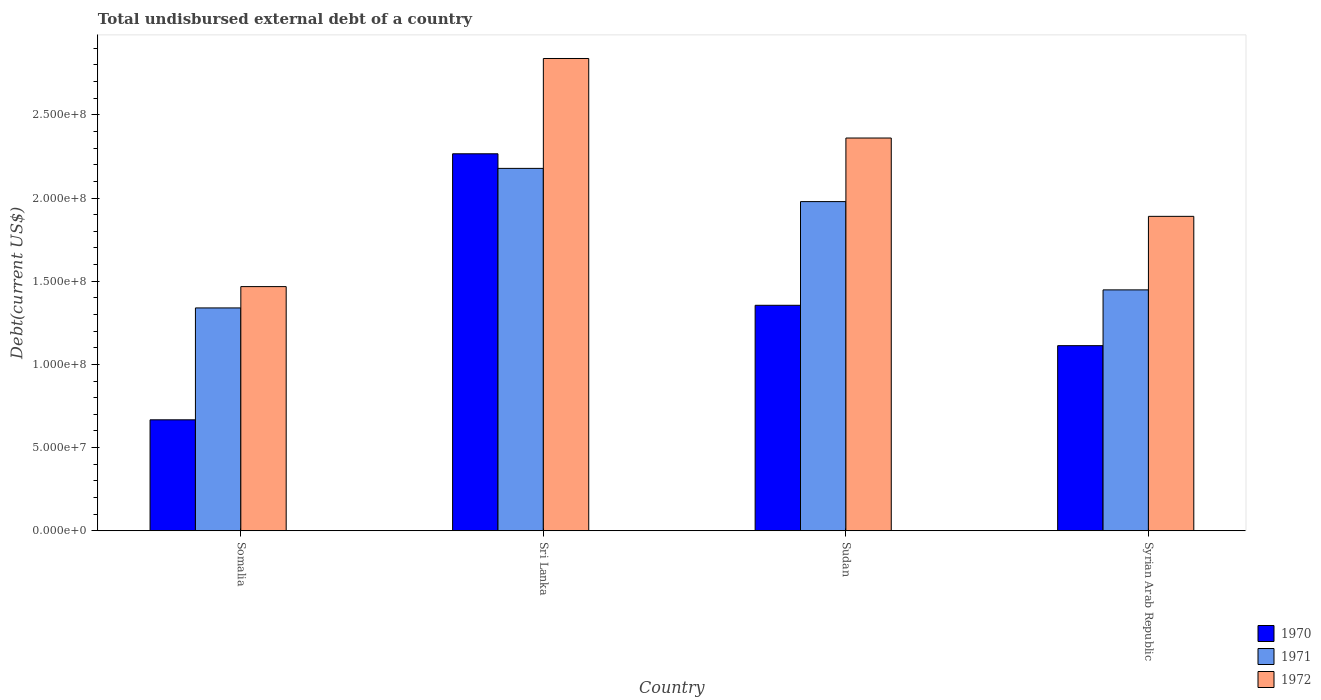How many different coloured bars are there?
Your answer should be compact. 3. Are the number of bars on each tick of the X-axis equal?
Your answer should be compact. Yes. What is the label of the 4th group of bars from the left?
Make the answer very short. Syrian Arab Republic. In how many cases, is the number of bars for a given country not equal to the number of legend labels?
Offer a very short reply. 0. What is the total undisbursed external debt in 1971 in Somalia?
Ensure brevity in your answer.  1.34e+08. Across all countries, what is the maximum total undisbursed external debt in 1972?
Your response must be concise. 2.84e+08. Across all countries, what is the minimum total undisbursed external debt in 1972?
Your answer should be compact. 1.47e+08. In which country was the total undisbursed external debt in 1970 maximum?
Offer a terse response. Sri Lanka. In which country was the total undisbursed external debt in 1971 minimum?
Offer a terse response. Somalia. What is the total total undisbursed external debt in 1970 in the graph?
Ensure brevity in your answer.  5.40e+08. What is the difference between the total undisbursed external debt in 1971 in Sri Lanka and that in Syrian Arab Republic?
Make the answer very short. 7.30e+07. What is the difference between the total undisbursed external debt in 1972 in Syrian Arab Republic and the total undisbursed external debt in 1971 in Sri Lanka?
Your answer should be compact. -2.88e+07. What is the average total undisbursed external debt in 1970 per country?
Provide a short and direct response. 1.35e+08. What is the difference between the total undisbursed external debt of/in 1972 and total undisbursed external debt of/in 1971 in Somalia?
Your response must be concise. 1.28e+07. In how many countries, is the total undisbursed external debt in 1970 greater than 270000000 US$?
Ensure brevity in your answer.  0. What is the ratio of the total undisbursed external debt in 1972 in Somalia to that in Sudan?
Keep it short and to the point. 0.62. Is the total undisbursed external debt in 1972 in Somalia less than that in Syrian Arab Republic?
Offer a very short reply. Yes. What is the difference between the highest and the second highest total undisbursed external debt in 1970?
Provide a succinct answer. 1.15e+08. What is the difference between the highest and the lowest total undisbursed external debt in 1972?
Ensure brevity in your answer.  1.37e+08. In how many countries, is the total undisbursed external debt in 1970 greater than the average total undisbursed external debt in 1970 taken over all countries?
Offer a very short reply. 2. How many bars are there?
Your response must be concise. 12. Are all the bars in the graph horizontal?
Provide a short and direct response. No. Does the graph contain grids?
Give a very brief answer. No. Where does the legend appear in the graph?
Offer a terse response. Bottom right. How are the legend labels stacked?
Offer a very short reply. Vertical. What is the title of the graph?
Your answer should be compact. Total undisbursed external debt of a country. Does "1978" appear as one of the legend labels in the graph?
Offer a very short reply. No. What is the label or title of the X-axis?
Provide a short and direct response. Country. What is the label or title of the Y-axis?
Offer a very short reply. Debt(current US$). What is the Debt(current US$) in 1970 in Somalia?
Keep it short and to the point. 6.67e+07. What is the Debt(current US$) in 1971 in Somalia?
Provide a succinct answer. 1.34e+08. What is the Debt(current US$) in 1972 in Somalia?
Offer a very short reply. 1.47e+08. What is the Debt(current US$) of 1970 in Sri Lanka?
Your answer should be compact. 2.27e+08. What is the Debt(current US$) in 1971 in Sri Lanka?
Your response must be concise. 2.18e+08. What is the Debt(current US$) of 1972 in Sri Lanka?
Offer a very short reply. 2.84e+08. What is the Debt(current US$) in 1970 in Sudan?
Provide a succinct answer. 1.36e+08. What is the Debt(current US$) of 1971 in Sudan?
Keep it short and to the point. 1.98e+08. What is the Debt(current US$) of 1972 in Sudan?
Provide a short and direct response. 2.36e+08. What is the Debt(current US$) of 1970 in Syrian Arab Republic?
Offer a terse response. 1.11e+08. What is the Debt(current US$) in 1971 in Syrian Arab Republic?
Your response must be concise. 1.45e+08. What is the Debt(current US$) in 1972 in Syrian Arab Republic?
Your response must be concise. 1.89e+08. Across all countries, what is the maximum Debt(current US$) of 1970?
Offer a terse response. 2.27e+08. Across all countries, what is the maximum Debt(current US$) in 1971?
Offer a terse response. 2.18e+08. Across all countries, what is the maximum Debt(current US$) of 1972?
Keep it short and to the point. 2.84e+08. Across all countries, what is the minimum Debt(current US$) of 1970?
Provide a succinct answer. 6.67e+07. Across all countries, what is the minimum Debt(current US$) in 1971?
Offer a terse response. 1.34e+08. Across all countries, what is the minimum Debt(current US$) of 1972?
Make the answer very short. 1.47e+08. What is the total Debt(current US$) in 1970 in the graph?
Keep it short and to the point. 5.40e+08. What is the total Debt(current US$) of 1971 in the graph?
Offer a terse response. 6.94e+08. What is the total Debt(current US$) in 1972 in the graph?
Your answer should be very brief. 8.56e+08. What is the difference between the Debt(current US$) in 1970 in Somalia and that in Sri Lanka?
Offer a very short reply. -1.60e+08. What is the difference between the Debt(current US$) in 1971 in Somalia and that in Sri Lanka?
Give a very brief answer. -8.39e+07. What is the difference between the Debt(current US$) in 1972 in Somalia and that in Sri Lanka?
Offer a terse response. -1.37e+08. What is the difference between the Debt(current US$) of 1970 in Somalia and that in Sudan?
Keep it short and to the point. -6.88e+07. What is the difference between the Debt(current US$) of 1971 in Somalia and that in Sudan?
Ensure brevity in your answer.  -6.39e+07. What is the difference between the Debt(current US$) of 1972 in Somalia and that in Sudan?
Offer a terse response. -8.93e+07. What is the difference between the Debt(current US$) of 1970 in Somalia and that in Syrian Arab Republic?
Ensure brevity in your answer.  -4.46e+07. What is the difference between the Debt(current US$) in 1971 in Somalia and that in Syrian Arab Republic?
Make the answer very short. -1.08e+07. What is the difference between the Debt(current US$) of 1972 in Somalia and that in Syrian Arab Republic?
Ensure brevity in your answer.  -4.22e+07. What is the difference between the Debt(current US$) of 1970 in Sri Lanka and that in Sudan?
Ensure brevity in your answer.  9.11e+07. What is the difference between the Debt(current US$) in 1971 in Sri Lanka and that in Sudan?
Provide a succinct answer. 2.00e+07. What is the difference between the Debt(current US$) of 1972 in Sri Lanka and that in Sudan?
Offer a terse response. 4.78e+07. What is the difference between the Debt(current US$) of 1970 in Sri Lanka and that in Syrian Arab Republic?
Make the answer very short. 1.15e+08. What is the difference between the Debt(current US$) in 1971 in Sri Lanka and that in Syrian Arab Republic?
Offer a very short reply. 7.30e+07. What is the difference between the Debt(current US$) of 1972 in Sri Lanka and that in Syrian Arab Republic?
Your response must be concise. 9.49e+07. What is the difference between the Debt(current US$) in 1970 in Sudan and that in Syrian Arab Republic?
Your response must be concise. 2.43e+07. What is the difference between the Debt(current US$) of 1971 in Sudan and that in Syrian Arab Republic?
Ensure brevity in your answer.  5.31e+07. What is the difference between the Debt(current US$) in 1972 in Sudan and that in Syrian Arab Republic?
Make the answer very short. 4.71e+07. What is the difference between the Debt(current US$) in 1970 in Somalia and the Debt(current US$) in 1971 in Sri Lanka?
Your answer should be very brief. -1.51e+08. What is the difference between the Debt(current US$) of 1970 in Somalia and the Debt(current US$) of 1972 in Sri Lanka?
Provide a succinct answer. -2.17e+08. What is the difference between the Debt(current US$) in 1971 in Somalia and the Debt(current US$) in 1972 in Sri Lanka?
Offer a very short reply. -1.50e+08. What is the difference between the Debt(current US$) of 1970 in Somalia and the Debt(current US$) of 1971 in Sudan?
Your answer should be very brief. -1.31e+08. What is the difference between the Debt(current US$) of 1970 in Somalia and the Debt(current US$) of 1972 in Sudan?
Give a very brief answer. -1.69e+08. What is the difference between the Debt(current US$) in 1971 in Somalia and the Debt(current US$) in 1972 in Sudan?
Provide a succinct answer. -1.02e+08. What is the difference between the Debt(current US$) in 1970 in Somalia and the Debt(current US$) in 1971 in Syrian Arab Republic?
Ensure brevity in your answer.  -7.81e+07. What is the difference between the Debt(current US$) in 1970 in Somalia and the Debt(current US$) in 1972 in Syrian Arab Republic?
Make the answer very short. -1.22e+08. What is the difference between the Debt(current US$) of 1971 in Somalia and the Debt(current US$) of 1972 in Syrian Arab Republic?
Keep it short and to the point. -5.50e+07. What is the difference between the Debt(current US$) of 1970 in Sri Lanka and the Debt(current US$) of 1971 in Sudan?
Offer a terse response. 2.87e+07. What is the difference between the Debt(current US$) of 1970 in Sri Lanka and the Debt(current US$) of 1972 in Sudan?
Offer a terse response. -9.47e+06. What is the difference between the Debt(current US$) of 1971 in Sri Lanka and the Debt(current US$) of 1972 in Sudan?
Keep it short and to the point. -1.82e+07. What is the difference between the Debt(current US$) in 1970 in Sri Lanka and the Debt(current US$) in 1971 in Syrian Arab Republic?
Offer a terse response. 8.18e+07. What is the difference between the Debt(current US$) of 1970 in Sri Lanka and the Debt(current US$) of 1972 in Syrian Arab Republic?
Offer a very short reply. 3.76e+07. What is the difference between the Debt(current US$) in 1971 in Sri Lanka and the Debt(current US$) in 1972 in Syrian Arab Republic?
Your response must be concise. 2.88e+07. What is the difference between the Debt(current US$) in 1970 in Sudan and the Debt(current US$) in 1971 in Syrian Arab Republic?
Offer a very short reply. -9.26e+06. What is the difference between the Debt(current US$) in 1970 in Sudan and the Debt(current US$) in 1972 in Syrian Arab Republic?
Your answer should be very brief. -5.35e+07. What is the difference between the Debt(current US$) in 1971 in Sudan and the Debt(current US$) in 1972 in Syrian Arab Republic?
Your answer should be very brief. 8.87e+06. What is the average Debt(current US$) in 1970 per country?
Your answer should be compact. 1.35e+08. What is the average Debt(current US$) of 1971 per country?
Make the answer very short. 1.74e+08. What is the average Debt(current US$) in 1972 per country?
Provide a succinct answer. 2.14e+08. What is the difference between the Debt(current US$) in 1970 and Debt(current US$) in 1971 in Somalia?
Your answer should be compact. -6.73e+07. What is the difference between the Debt(current US$) in 1970 and Debt(current US$) in 1972 in Somalia?
Your answer should be compact. -8.01e+07. What is the difference between the Debt(current US$) in 1971 and Debt(current US$) in 1972 in Somalia?
Your response must be concise. -1.28e+07. What is the difference between the Debt(current US$) of 1970 and Debt(current US$) of 1971 in Sri Lanka?
Your answer should be compact. 8.78e+06. What is the difference between the Debt(current US$) of 1970 and Debt(current US$) of 1972 in Sri Lanka?
Your answer should be compact. -5.73e+07. What is the difference between the Debt(current US$) of 1971 and Debt(current US$) of 1972 in Sri Lanka?
Keep it short and to the point. -6.61e+07. What is the difference between the Debt(current US$) of 1970 and Debt(current US$) of 1971 in Sudan?
Your answer should be compact. -6.23e+07. What is the difference between the Debt(current US$) in 1970 and Debt(current US$) in 1972 in Sudan?
Offer a terse response. -1.01e+08. What is the difference between the Debt(current US$) of 1971 and Debt(current US$) of 1972 in Sudan?
Offer a terse response. -3.82e+07. What is the difference between the Debt(current US$) of 1970 and Debt(current US$) of 1971 in Syrian Arab Republic?
Your answer should be compact. -3.35e+07. What is the difference between the Debt(current US$) in 1970 and Debt(current US$) in 1972 in Syrian Arab Republic?
Your answer should be compact. -7.77e+07. What is the difference between the Debt(current US$) of 1971 and Debt(current US$) of 1972 in Syrian Arab Republic?
Give a very brief answer. -4.42e+07. What is the ratio of the Debt(current US$) of 1970 in Somalia to that in Sri Lanka?
Provide a short and direct response. 0.29. What is the ratio of the Debt(current US$) of 1971 in Somalia to that in Sri Lanka?
Your response must be concise. 0.61. What is the ratio of the Debt(current US$) of 1972 in Somalia to that in Sri Lanka?
Provide a short and direct response. 0.52. What is the ratio of the Debt(current US$) in 1970 in Somalia to that in Sudan?
Offer a very short reply. 0.49. What is the ratio of the Debt(current US$) in 1971 in Somalia to that in Sudan?
Make the answer very short. 0.68. What is the ratio of the Debt(current US$) of 1972 in Somalia to that in Sudan?
Provide a succinct answer. 0.62. What is the ratio of the Debt(current US$) in 1970 in Somalia to that in Syrian Arab Republic?
Give a very brief answer. 0.6. What is the ratio of the Debt(current US$) in 1971 in Somalia to that in Syrian Arab Republic?
Provide a short and direct response. 0.93. What is the ratio of the Debt(current US$) in 1972 in Somalia to that in Syrian Arab Republic?
Give a very brief answer. 0.78. What is the ratio of the Debt(current US$) in 1970 in Sri Lanka to that in Sudan?
Provide a succinct answer. 1.67. What is the ratio of the Debt(current US$) of 1971 in Sri Lanka to that in Sudan?
Make the answer very short. 1.1. What is the ratio of the Debt(current US$) of 1972 in Sri Lanka to that in Sudan?
Provide a short and direct response. 1.2. What is the ratio of the Debt(current US$) of 1970 in Sri Lanka to that in Syrian Arab Republic?
Your response must be concise. 2.04. What is the ratio of the Debt(current US$) of 1971 in Sri Lanka to that in Syrian Arab Republic?
Provide a short and direct response. 1.5. What is the ratio of the Debt(current US$) of 1972 in Sri Lanka to that in Syrian Arab Republic?
Give a very brief answer. 1.5. What is the ratio of the Debt(current US$) of 1970 in Sudan to that in Syrian Arab Republic?
Offer a terse response. 1.22. What is the ratio of the Debt(current US$) in 1971 in Sudan to that in Syrian Arab Republic?
Provide a short and direct response. 1.37. What is the ratio of the Debt(current US$) of 1972 in Sudan to that in Syrian Arab Republic?
Provide a short and direct response. 1.25. What is the difference between the highest and the second highest Debt(current US$) of 1970?
Keep it short and to the point. 9.11e+07. What is the difference between the highest and the second highest Debt(current US$) in 1971?
Your response must be concise. 2.00e+07. What is the difference between the highest and the second highest Debt(current US$) of 1972?
Keep it short and to the point. 4.78e+07. What is the difference between the highest and the lowest Debt(current US$) in 1970?
Keep it short and to the point. 1.60e+08. What is the difference between the highest and the lowest Debt(current US$) of 1971?
Provide a succinct answer. 8.39e+07. What is the difference between the highest and the lowest Debt(current US$) of 1972?
Provide a short and direct response. 1.37e+08. 